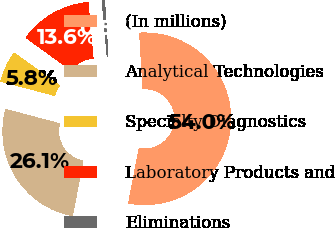<chart> <loc_0><loc_0><loc_500><loc_500><pie_chart><fcel>(In millions)<fcel>Analytical Technologies<fcel>Specialty Diagnostics<fcel>Laboratory Products and<fcel>Eliminations<nl><fcel>54.0%<fcel>26.1%<fcel>5.82%<fcel>13.61%<fcel>0.47%<nl></chart> 